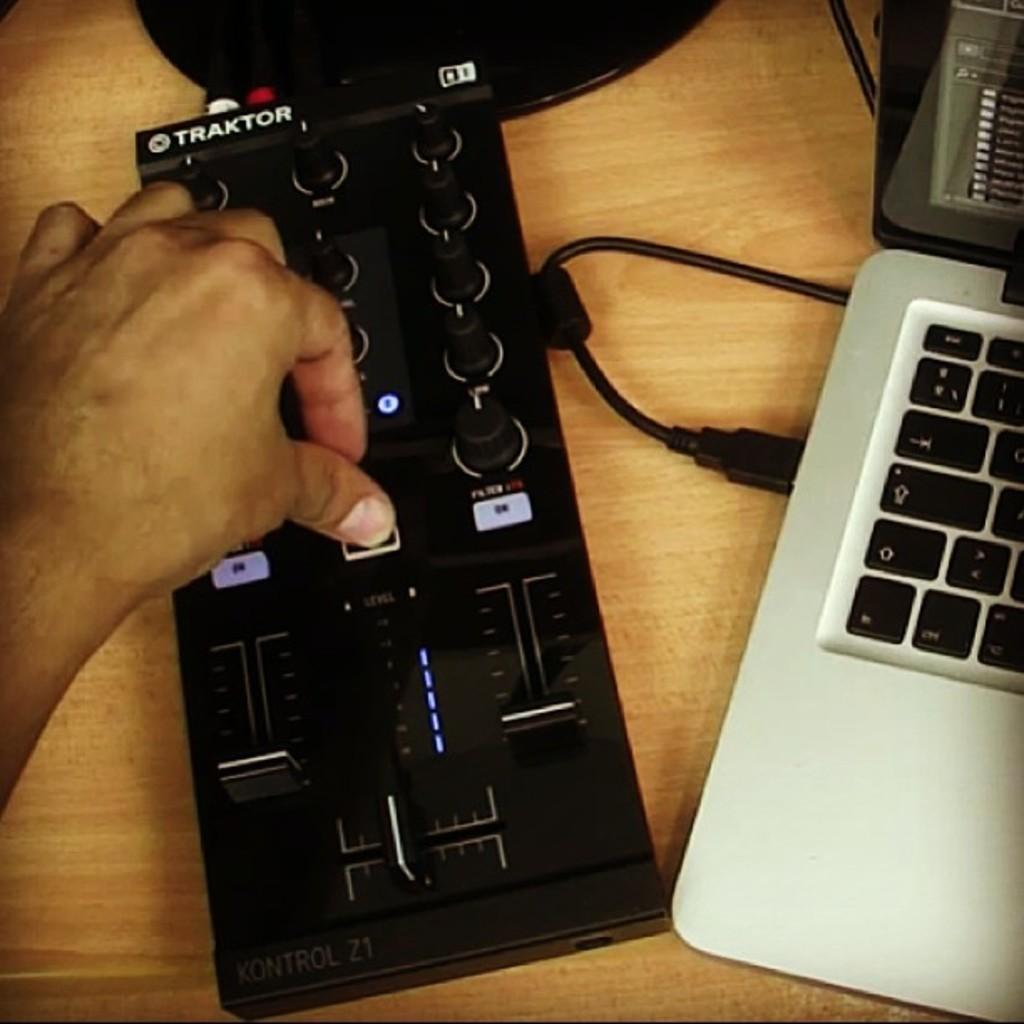<image>
Relay a brief, clear account of the picture shown. somebody is pushing a button on a Traktor device 